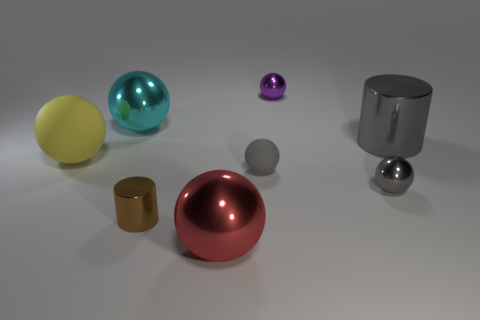Subtract all large cyan shiny balls. How many balls are left? 5 Subtract all purple spheres. How many spheres are left? 5 Subtract all blue spheres. Subtract all green cylinders. How many spheres are left? 6 Add 2 gray shiny balls. How many objects exist? 10 Subtract all cylinders. How many objects are left? 6 Subtract all small red shiny blocks. Subtract all gray spheres. How many objects are left? 6 Add 3 tiny metallic spheres. How many tiny metallic spheres are left? 5 Add 2 tiny brown cylinders. How many tiny brown cylinders exist? 3 Subtract 1 yellow balls. How many objects are left? 7 